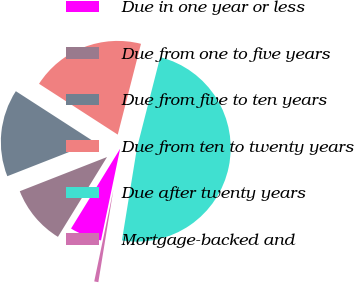<chart> <loc_0><loc_0><loc_500><loc_500><pie_chart><fcel>Due in one year or less<fcel>Due from one to five years<fcel>Due from five to ten years<fcel>Due from ten to twenty years<fcel>Due after twenty years<fcel>Mortgage-backed and<nl><fcel>5.5%<fcel>10.28%<fcel>15.07%<fcel>19.86%<fcel>48.58%<fcel>0.71%<nl></chart> 